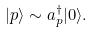<formula> <loc_0><loc_0><loc_500><loc_500>| p \rangle \sim a _ { p } ^ { \dagger } | 0 \rangle .</formula> 